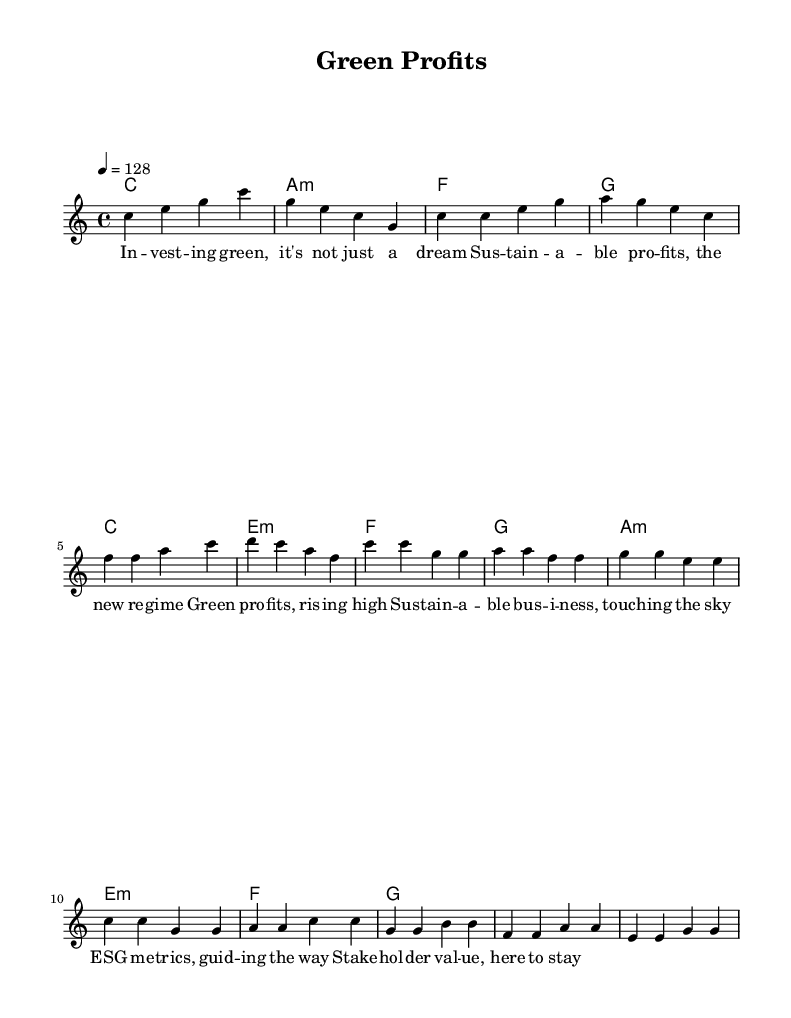What is the key signature of this music? The key signature is C major, which has no sharps or flats.
Answer: C major What is the time signature of this piece? The time signature is 4/4, indicating four beats per measure.
Answer: 4/4 What is the tempo of the song? The tempo marking indicates a speed of 128 beats per minute, suggesting an upbeat pacing.
Answer: 128 What section follows the verse in the structure? The section following the verse is the chorus, which provides the main theme of the song.
Answer: Chorus How many measures are there in the chorus? The chorus consists of four measures, as indicated by the four distinct musical phrases.
Answer: Four measures What is the primary theme expressed in the lyrics? The lyrics focus on sustainable business practices and the idea of investing in green initiatives.
Answer: Sustainable business practices What musical term describes the repeated pattern in the chorus? The repeated musical phrasing in the chorus can be described as a hook, a common element in dance music to create catchiness.
Answer: Hook 